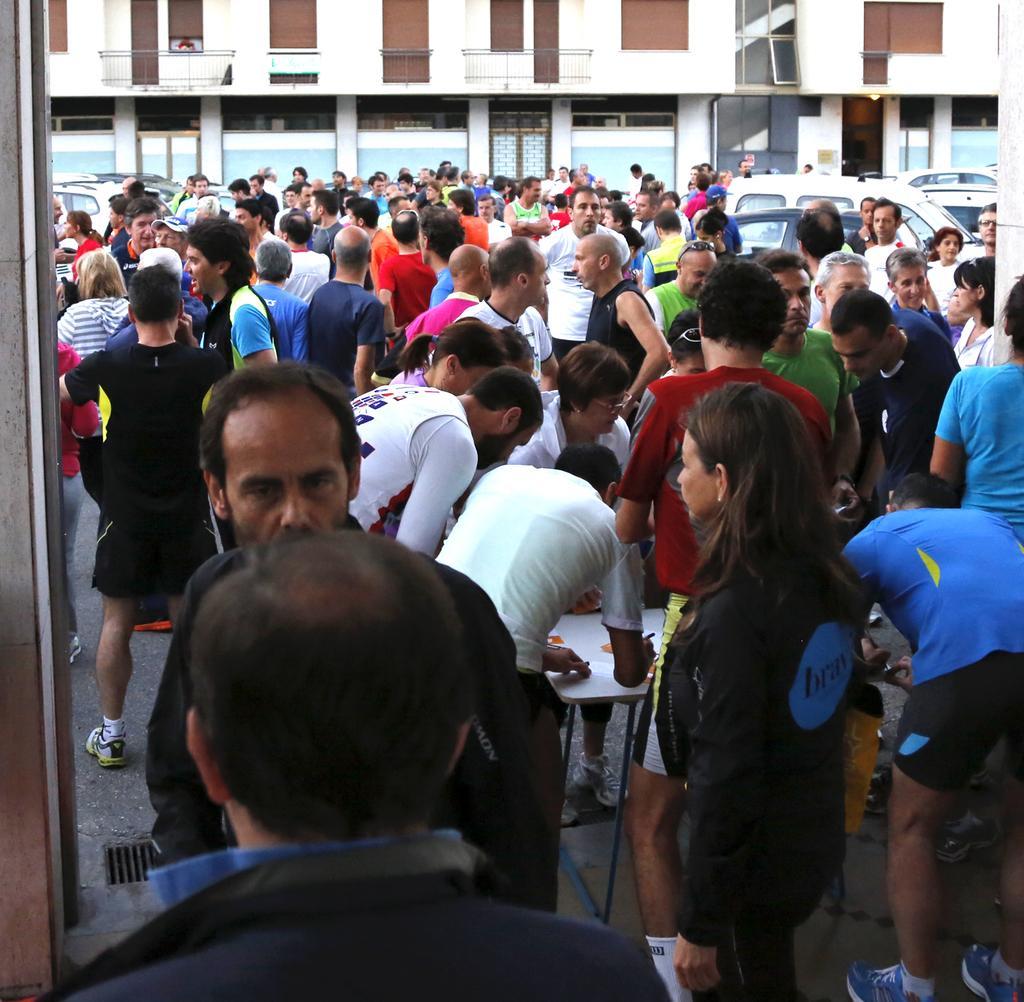In one or two sentences, can you explain what this image depicts? In this image in front there are people standing in front of the table. Behind them there are a few other people standing on the road. In the background of the image there are cars, buildings. 